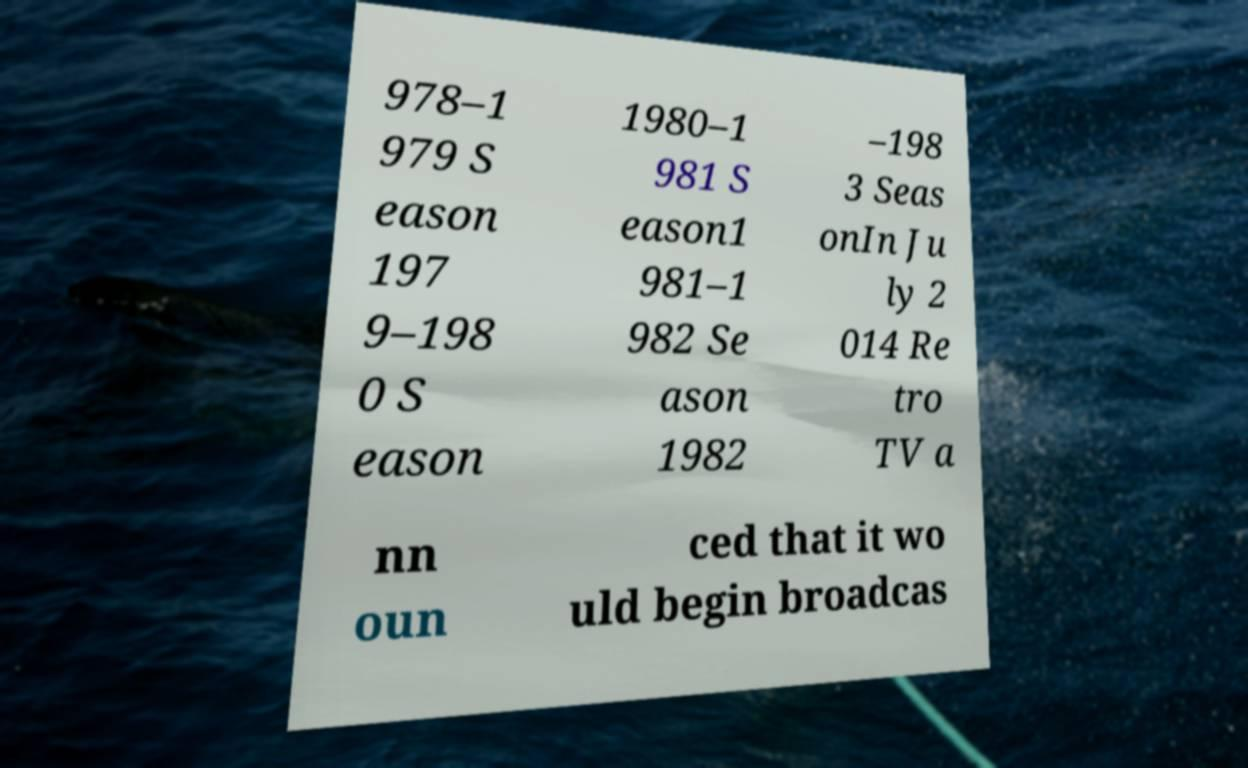Could you assist in decoding the text presented in this image and type it out clearly? 978–1 979 S eason 197 9–198 0 S eason 1980–1 981 S eason1 981–1 982 Se ason 1982 –198 3 Seas onIn Ju ly 2 014 Re tro TV a nn oun ced that it wo uld begin broadcas 